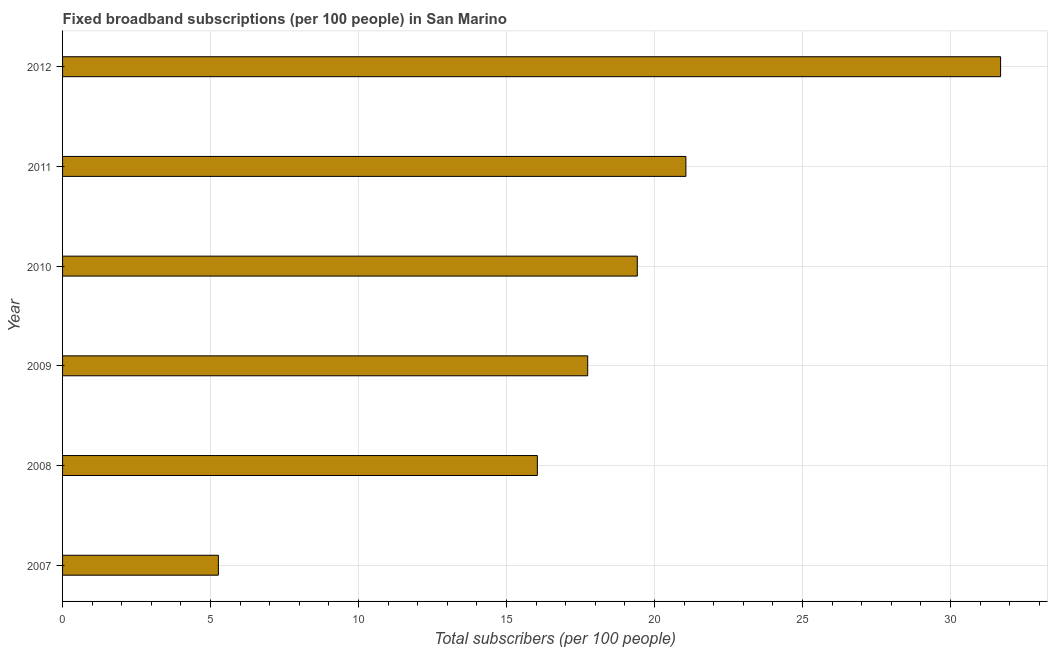Does the graph contain any zero values?
Provide a succinct answer. No. Does the graph contain grids?
Your answer should be very brief. Yes. What is the title of the graph?
Make the answer very short. Fixed broadband subscriptions (per 100 people) in San Marino. What is the label or title of the X-axis?
Make the answer very short. Total subscribers (per 100 people). What is the label or title of the Y-axis?
Provide a succinct answer. Year. What is the total number of fixed broadband subscriptions in 2009?
Your answer should be very brief. 17.74. Across all years, what is the maximum total number of fixed broadband subscriptions?
Your answer should be very brief. 31.69. Across all years, what is the minimum total number of fixed broadband subscriptions?
Your answer should be very brief. 5.26. In which year was the total number of fixed broadband subscriptions maximum?
Keep it short and to the point. 2012. What is the sum of the total number of fixed broadband subscriptions?
Provide a succinct answer. 111.21. What is the difference between the total number of fixed broadband subscriptions in 2009 and 2010?
Your answer should be very brief. -1.68. What is the average total number of fixed broadband subscriptions per year?
Provide a succinct answer. 18.54. What is the median total number of fixed broadband subscriptions?
Keep it short and to the point. 18.58. What is the ratio of the total number of fixed broadband subscriptions in 2009 to that in 2010?
Your answer should be compact. 0.91. What is the difference between the highest and the second highest total number of fixed broadband subscriptions?
Provide a succinct answer. 10.63. Is the sum of the total number of fixed broadband subscriptions in 2007 and 2010 greater than the maximum total number of fixed broadband subscriptions across all years?
Provide a succinct answer. No. What is the difference between the highest and the lowest total number of fixed broadband subscriptions?
Give a very brief answer. 26.43. How many bars are there?
Your response must be concise. 6. Are all the bars in the graph horizontal?
Make the answer very short. Yes. How many years are there in the graph?
Keep it short and to the point. 6. What is the difference between two consecutive major ticks on the X-axis?
Offer a terse response. 5. What is the Total subscribers (per 100 people) of 2007?
Ensure brevity in your answer.  5.26. What is the Total subscribers (per 100 people) in 2008?
Provide a short and direct response. 16.04. What is the Total subscribers (per 100 people) in 2009?
Your answer should be compact. 17.74. What is the Total subscribers (per 100 people) in 2010?
Your answer should be compact. 19.42. What is the Total subscribers (per 100 people) of 2011?
Your answer should be compact. 21.06. What is the Total subscribers (per 100 people) of 2012?
Offer a terse response. 31.69. What is the difference between the Total subscribers (per 100 people) in 2007 and 2008?
Ensure brevity in your answer.  -10.78. What is the difference between the Total subscribers (per 100 people) in 2007 and 2009?
Offer a terse response. -12.48. What is the difference between the Total subscribers (per 100 people) in 2007 and 2010?
Make the answer very short. -14.15. What is the difference between the Total subscribers (per 100 people) in 2007 and 2011?
Provide a short and direct response. -15.79. What is the difference between the Total subscribers (per 100 people) in 2007 and 2012?
Your response must be concise. -26.43. What is the difference between the Total subscribers (per 100 people) in 2008 and 2009?
Your response must be concise. -1.7. What is the difference between the Total subscribers (per 100 people) in 2008 and 2010?
Make the answer very short. -3.38. What is the difference between the Total subscribers (per 100 people) in 2008 and 2011?
Provide a succinct answer. -5.02. What is the difference between the Total subscribers (per 100 people) in 2008 and 2012?
Your answer should be compact. -15.65. What is the difference between the Total subscribers (per 100 people) in 2009 and 2010?
Offer a very short reply. -1.68. What is the difference between the Total subscribers (per 100 people) in 2009 and 2011?
Provide a succinct answer. -3.32. What is the difference between the Total subscribers (per 100 people) in 2009 and 2012?
Make the answer very short. -13.95. What is the difference between the Total subscribers (per 100 people) in 2010 and 2011?
Your response must be concise. -1.64. What is the difference between the Total subscribers (per 100 people) in 2010 and 2012?
Your response must be concise. -12.27. What is the difference between the Total subscribers (per 100 people) in 2011 and 2012?
Provide a short and direct response. -10.63. What is the ratio of the Total subscribers (per 100 people) in 2007 to that in 2008?
Provide a succinct answer. 0.33. What is the ratio of the Total subscribers (per 100 people) in 2007 to that in 2009?
Your answer should be very brief. 0.3. What is the ratio of the Total subscribers (per 100 people) in 2007 to that in 2010?
Provide a succinct answer. 0.27. What is the ratio of the Total subscribers (per 100 people) in 2007 to that in 2012?
Keep it short and to the point. 0.17. What is the ratio of the Total subscribers (per 100 people) in 2008 to that in 2009?
Ensure brevity in your answer.  0.9. What is the ratio of the Total subscribers (per 100 people) in 2008 to that in 2010?
Offer a very short reply. 0.83. What is the ratio of the Total subscribers (per 100 people) in 2008 to that in 2011?
Offer a very short reply. 0.76. What is the ratio of the Total subscribers (per 100 people) in 2008 to that in 2012?
Your answer should be compact. 0.51. What is the ratio of the Total subscribers (per 100 people) in 2009 to that in 2010?
Your answer should be compact. 0.91. What is the ratio of the Total subscribers (per 100 people) in 2009 to that in 2011?
Ensure brevity in your answer.  0.84. What is the ratio of the Total subscribers (per 100 people) in 2009 to that in 2012?
Provide a short and direct response. 0.56. What is the ratio of the Total subscribers (per 100 people) in 2010 to that in 2011?
Provide a short and direct response. 0.92. What is the ratio of the Total subscribers (per 100 people) in 2010 to that in 2012?
Your response must be concise. 0.61. What is the ratio of the Total subscribers (per 100 people) in 2011 to that in 2012?
Provide a short and direct response. 0.67. 